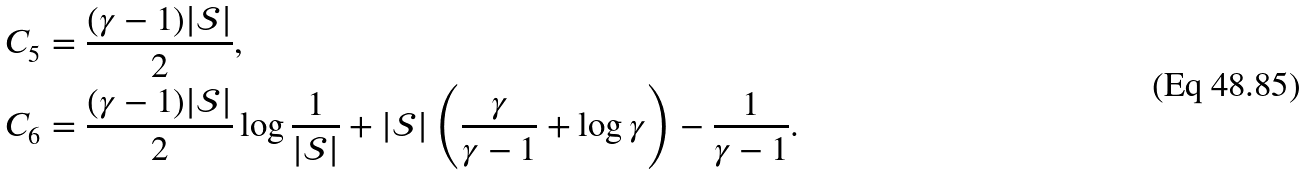<formula> <loc_0><loc_0><loc_500><loc_500>C _ { 5 } & = \frac { ( \gamma - 1 ) | \mathcal { S } | } { 2 } , \\ C _ { 6 } & = \frac { ( \gamma - 1 ) | \mathcal { S } | } { 2 } \log \frac { 1 } { | \mathcal { S } | } + | \mathcal { S } | \left ( \frac { \gamma } { \gamma - 1 } + \log \gamma \right ) - \frac { 1 } { \gamma - 1 } .</formula> 